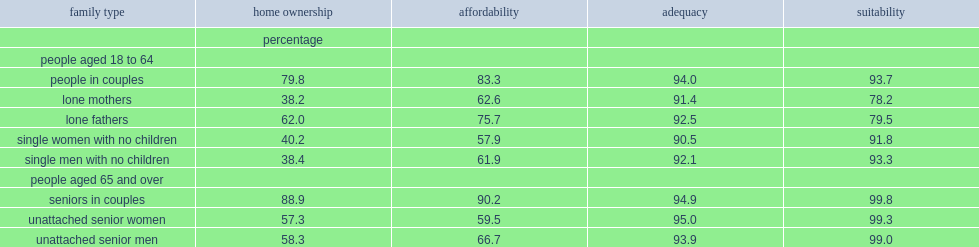What was the percentage of people in couples aged 18 to 64 lived in a home owned by oneself or a household member in 2015? 79.8. What was the percentage of people in couples aged 65 and over lived in a home owned by oneself or a household member in 2015? 88.9. What was the percentage of lone mothers aged 18 to 64 lived in a house owned by oneself or a household member in 2015? 38.2. What was the percentage of lone fathers aged 18 to 64 lived in a house owned by oneself or a household member in 2015? 62.0. What was the percentage of unattached senior women aged 65 and older lived in a home owned by a household member in 2015? 57.3. What was the percentage of unattached senior men aged 65 and older lived in a home owned by a household member in 2015? 58.3. What was the percentage of unattached women who had no children aged 18 to 64 lived in an owned home? 40.2. What was the percentage of unattached men who had no children aged 18 to 64 lived in an owned home? 38.4. What was the percentage of people in couples aged 18 to 64 had affordable housing? 83.3. What was the percentage of people in couples aged 18 to 64 had adequate housing? 94.0. What was the percentage of people in couples aged 18 to 64 had suitable housing? 93.7. What was the percentage of lone mothers aged 18 to 64 had affordable housing? 62.6. What was the percentage of lone fathers aged 18 to 64 had affordable housing? 75.7. What was the percentage of lone mothers aged 18 to 64 had adequate housing? 91.4. What was the percentage of lone fathers aged 18 to 64 had adequate housing? 92.5. What was the percentage of lone mothers aged 18 to 64 had suitable housing? 78.2. What was the percentage of lone fathers aged 18 to 64 had suitable housing? 79.5. For people aged 18 to 64,which sex of lone parents were less likely to be able to afford their housing?lone mothers or lone fathers? Lone mothers. For people aged 65 and older,which sex of unattached people were less likely to be able to afford their housing?unattached women or unattached men? Unattached senior women. 